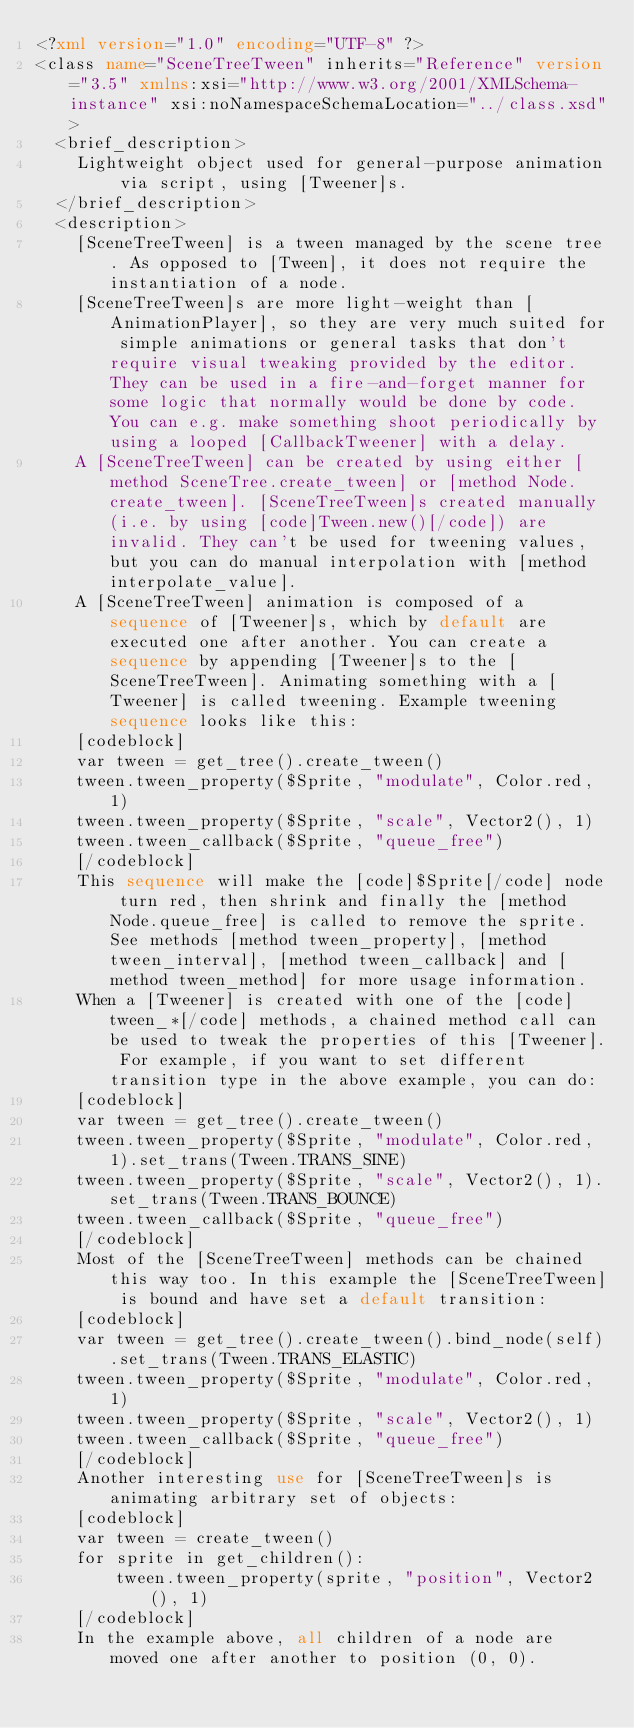Convert code to text. <code><loc_0><loc_0><loc_500><loc_500><_XML_><?xml version="1.0" encoding="UTF-8" ?>
<class name="SceneTreeTween" inherits="Reference" version="3.5" xmlns:xsi="http://www.w3.org/2001/XMLSchema-instance" xsi:noNamespaceSchemaLocation="../class.xsd">
	<brief_description>
		Lightweight object used for general-purpose animation via script, using [Tweener]s.
	</brief_description>
	<description>
		[SceneTreeTween] is a tween managed by the scene tree. As opposed to [Tween], it does not require the instantiation of a node.
		[SceneTreeTween]s are more light-weight than [AnimationPlayer], so they are very much suited for simple animations or general tasks that don't require visual tweaking provided by the editor. They can be used in a fire-and-forget manner for some logic that normally would be done by code. You can e.g. make something shoot periodically by using a looped [CallbackTweener] with a delay.
		A [SceneTreeTween] can be created by using either [method SceneTree.create_tween] or [method Node.create_tween]. [SceneTreeTween]s created manually (i.e. by using [code]Tween.new()[/code]) are invalid. They can't be used for tweening values, but you can do manual interpolation with [method interpolate_value].
		A [SceneTreeTween] animation is composed of a sequence of [Tweener]s, which by default are executed one after another. You can create a sequence by appending [Tweener]s to the [SceneTreeTween]. Animating something with a [Tweener] is called tweening. Example tweening sequence looks like this:
		[codeblock]
		var tween = get_tree().create_tween()
		tween.tween_property($Sprite, "modulate", Color.red, 1)
		tween.tween_property($Sprite, "scale", Vector2(), 1)
		tween.tween_callback($Sprite, "queue_free")
		[/codeblock]
		This sequence will make the [code]$Sprite[/code] node turn red, then shrink and finally the [method Node.queue_free] is called to remove the sprite. See methods [method tween_property], [method tween_interval], [method tween_callback] and [method tween_method] for more usage information.
		When a [Tweener] is created with one of the [code]tween_*[/code] methods, a chained method call can be used to tweak the properties of this [Tweener]. For example, if you want to set different transition type in the above example, you can do:
		[codeblock]
		var tween = get_tree().create_tween()
		tween.tween_property($Sprite, "modulate", Color.red, 1).set_trans(Tween.TRANS_SINE)
		tween.tween_property($Sprite, "scale", Vector2(), 1).set_trans(Tween.TRANS_BOUNCE)
		tween.tween_callback($Sprite, "queue_free")
		[/codeblock]
		Most of the [SceneTreeTween] methods can be chained this way too. In this example the [SceneTreeTween] is bound and have set a default transition:
		[codeblock]
		var tween = get_tree().create_tween().bind_node(self).set_trans(Tween.TRANS_ELASTIC)
		tween.tween_property($Sprite, "modulate", Color.red, 1)
		tween.tween_property($Sprite, "scale", Vector2(), 1)
		tween.tween_callback($Sprite, "queue_free")
		[/codeblock]
		Another interesting use for [SceneTreeTween]s is animating arbitrary set of objects:
		[codeblock]
		var tween = create_tween()
		for sprite in get_children():
		    tween.tween_property(sprite, "position", Vector2(), 1)
		[/codeblock]
		In the example above, all children of a node are moved one after another to position (0, 0).</code> 